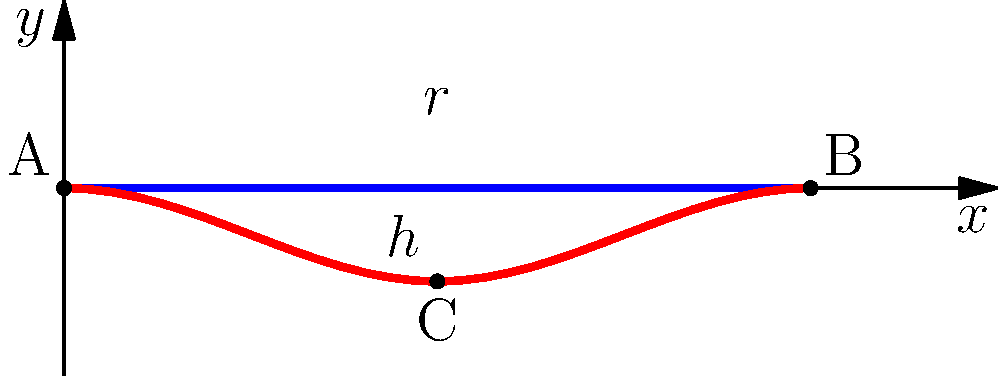As a retired golf professional, you're helping design a new golf ball. The cross-section of a dimple on the ball is shown above, where $r$ is the radius of the dimple and $h$ is its depth. If the dimple is rotated around the y-axis to form a volume, which mathematical method would be most appropriate to estimate this volume? To estimate the volume of the golf ball dimple, we need to consider its three-dimensional shape. The cross-section shown represents half of the dimple, which when rotated around the y-axis, forms a bowl-like shape. This type of problem is best solved using the method of volumes of revolution.

The steps to approach this problem are:

1. Recognize that the dimple forms a solid of revolution when rotated around the y-axis.

2. Identify that the curve representing the dimple's surface (shown in red) is the function we need to consider.

3. Understand that the volume can be calculated by integrating the area of circular disks perpendicular to the y-axis, from the bottom of the dimple to the surface of the ball.

4. Realize that this scenario is ideal for using the disk method, which is a specific application of the method of volumes of revolution.

5. The general formula for the disk method is:

   $$V = \pi \int_a^b [f(x)]^2 dx$$

   where $f(x)$ represents the function of the curve, and $a$ and $b$ are the limits of integration.

6. In this case, we would need to find a function that best fits the curve of the dimple, then apply the disk method formula.

Given the golfer's background and the complexity of the problem, the most appropriate method to estimate this volume is the disk method, which is a specific application of the method of volumes of revolution.
Answer: Disk method (volumes of revolution) 